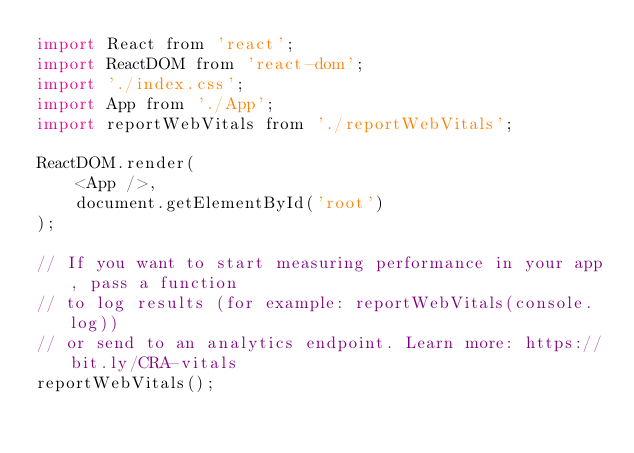<code> <loc_0><loc_0><loc_500><loc_500><_JavaScript_>import React from 'react';
import ReactDOM from 'react-dom';
import './index.css';
import App from './App';
import reportWebVitals from './reportWebVitals';

ReactDOM.render(
    <App />,
    document.getElementById('root')
);

// If you want to start measuring performance in your app, pass a function
// to log results (for example: reportWebVitals(console.log))
// or send to an analytics endpoint. Learn more: https://bit.ly/CRA-vitals
reportWebVitals();
</code> 